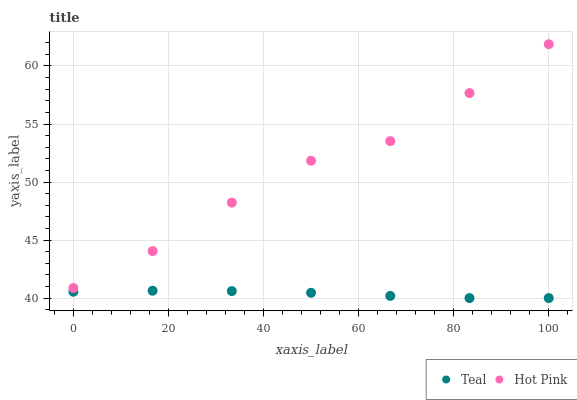Does Teal have the minimum area under the curve?
Answer yes or no. Yes. Does Hot Pink have the maximum area under the curve?
Answer yes or no. Yes. Does Teal have the maximum area under the curve?
Answer yes or no. No. Is Teal the smoothest?
Answer yes or no. Yes. Is Hot Pink the roughest?
Answer yes or no. Yes. Is Teal the roughest?
Answer yes or no. No. Does Teal have the lowest value?
Answer yes or no. Yes. Does Hot Pink have the highest value?
Answer yes or no. Yes. Does Teal have the highest value?
Answer yes or no. No. Is Teal less than Hot Pink?
Answer yes or no. Yes. Is Hot Pink greater than Teal?
Answer yes or no. Yes. Does Teal intersect Hot Pink?
Answer yes or no. No. 